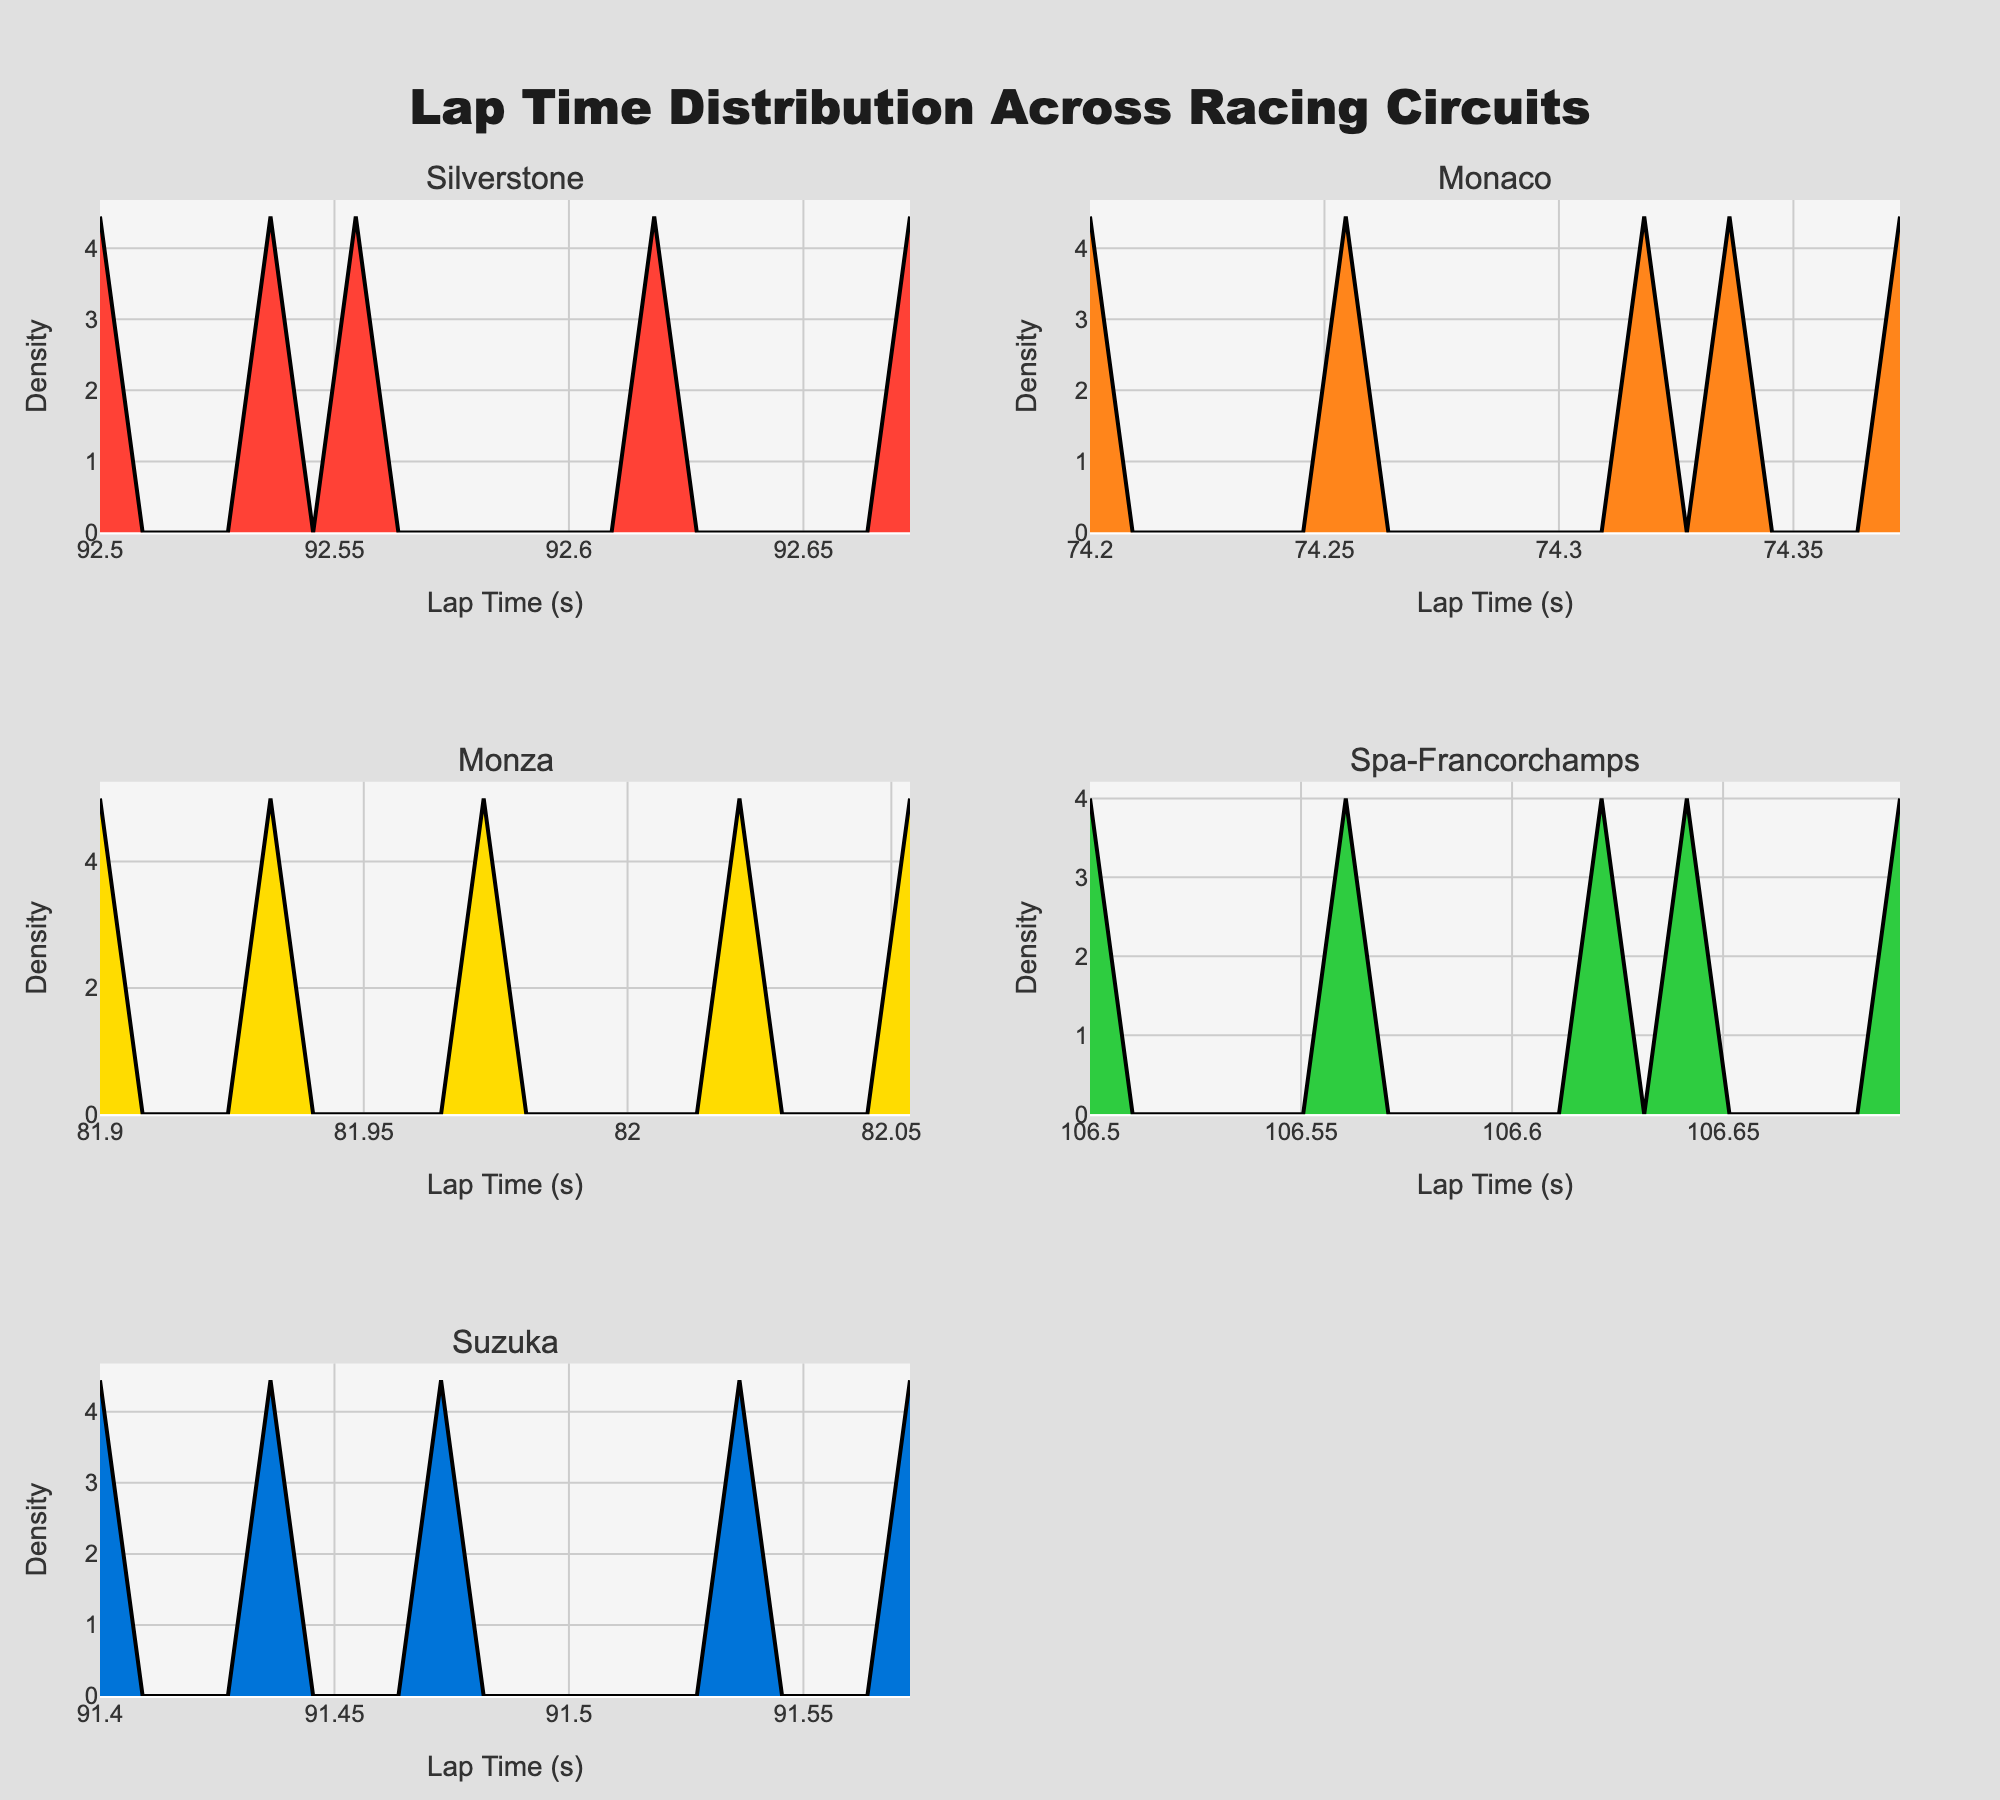What is the title of the plot? The title is displayed at the top of the figure and provides an overview of what the plot represents.
Answer: Lap Time Distribution Across Racing Circuits What is the x-axis labeled as? The x-axis label can be found at the bottom of each subplot and indicates what the horizontal axis represents.
Answer: Lap Time (s) Which circuit shows the densest distribution of lap times? To determine the densest distribution, look for the subplot with the highest peak in the density plot. This indicates the most frequent lap times.
Answer: Spa-Francorchamps What is the range of lap times at the Silverstone circuit? Identify the minimum and maximum values on the x-axis of the Silverstone subplot to find the range of lap times.
Answer: 92.5 to 93.4 seconds Which race circuit has the shortest lap time? Examine the x-axis of each subplot to find the lowest value, which represents the shortest lap time.
Answer: Monaco How do the lap times of Suzuka compare to those of Silverstone? Compare the x-axis ranges and densities of the two subplots to observe differences in lap time distributions. Suzuka has slightly shorter lap times and a different density pattern.
Answer: Suzuka has shorter lap times Which circuit has the widest range of lap times? By evaluating the x-axis range across all subplots, determine which circuit's lap time distribution spans the widest range.
Answer: Spa-Francorchamps How does the peak density value of Monaco compare to Monza? Compare the highest peak of the density plot in Monaco's subplot with that of Monza's to see which is higher.
Answer: Monaco has a higher peak density Are there any circuits with overlapping lap time ranges? Check if the x-axis ranges for any circuits overlap, indicating that the lap times for those circuits fall within similar intervals.
Answer: Silverstone and Suzuka What does the area under the density curve represent? The area under the density curve represents the distribution of lap times, giving a sense of how frequent certain lap times are. It should integrate to 1 across each circuit.
Answer: Distribution of lap times 